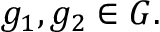<formula> <loc_0><loc_0><loc_500><loc_500>g _ { 1 } , g _ { 2 } \in G .</formula> 